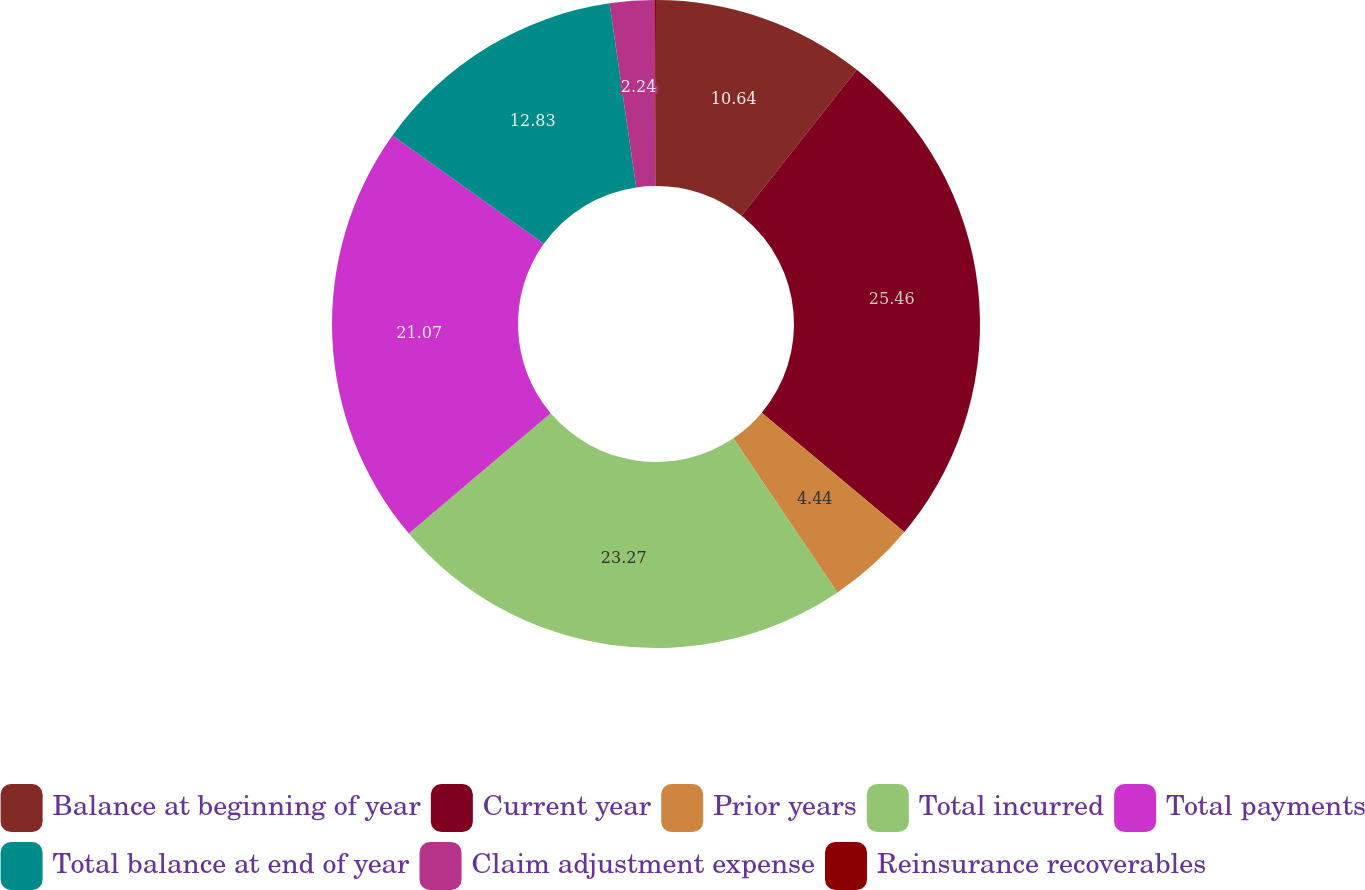Convert chart to OTSL. <chart><loc_0><loc_0><loc_500><loc_500><pie_chart><fcel>Balance at beginning of year<fcel>Current year<fcel>Prior years<fcel>Total incurred<fcel>Total payments<fcel>Total balance at end of year<fcel>Claim adjustment expense<fcel>Reinsurance recoverables<nl><fcel>10.64%<fcel>25.46%<fcel>4.44%<fcel>23.27%<fcel>21.07%<fcel>12.83%<fcel>2.24%<fcel>0.05%<nl></chart> 